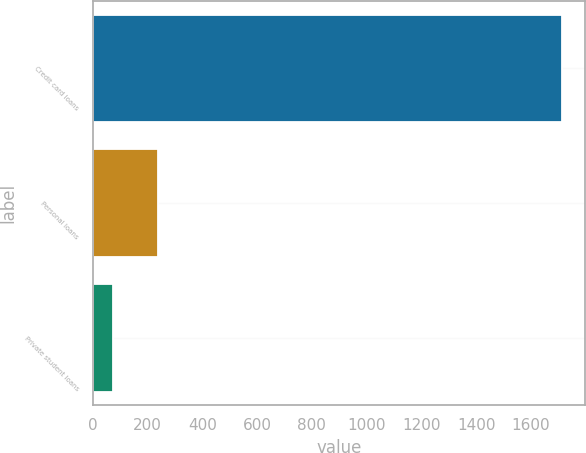Convert chart to OTSL. <chart><loc_0><loc_0><loc_500><loc_500><bar_chart><fcel>Credit card loans<fcel>Personal loans<fcel>Private student loans<nl><fcel>1713<fcel>237.9<fcel>74<nl></chart> 